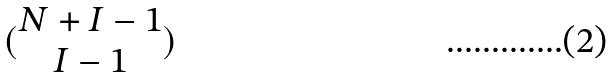<formula> <loc_0><loc_0><loc_500><loc_500>( \begin{matrix} N + I - 1 \\ I - 1 \end{matrix} )</formula> 